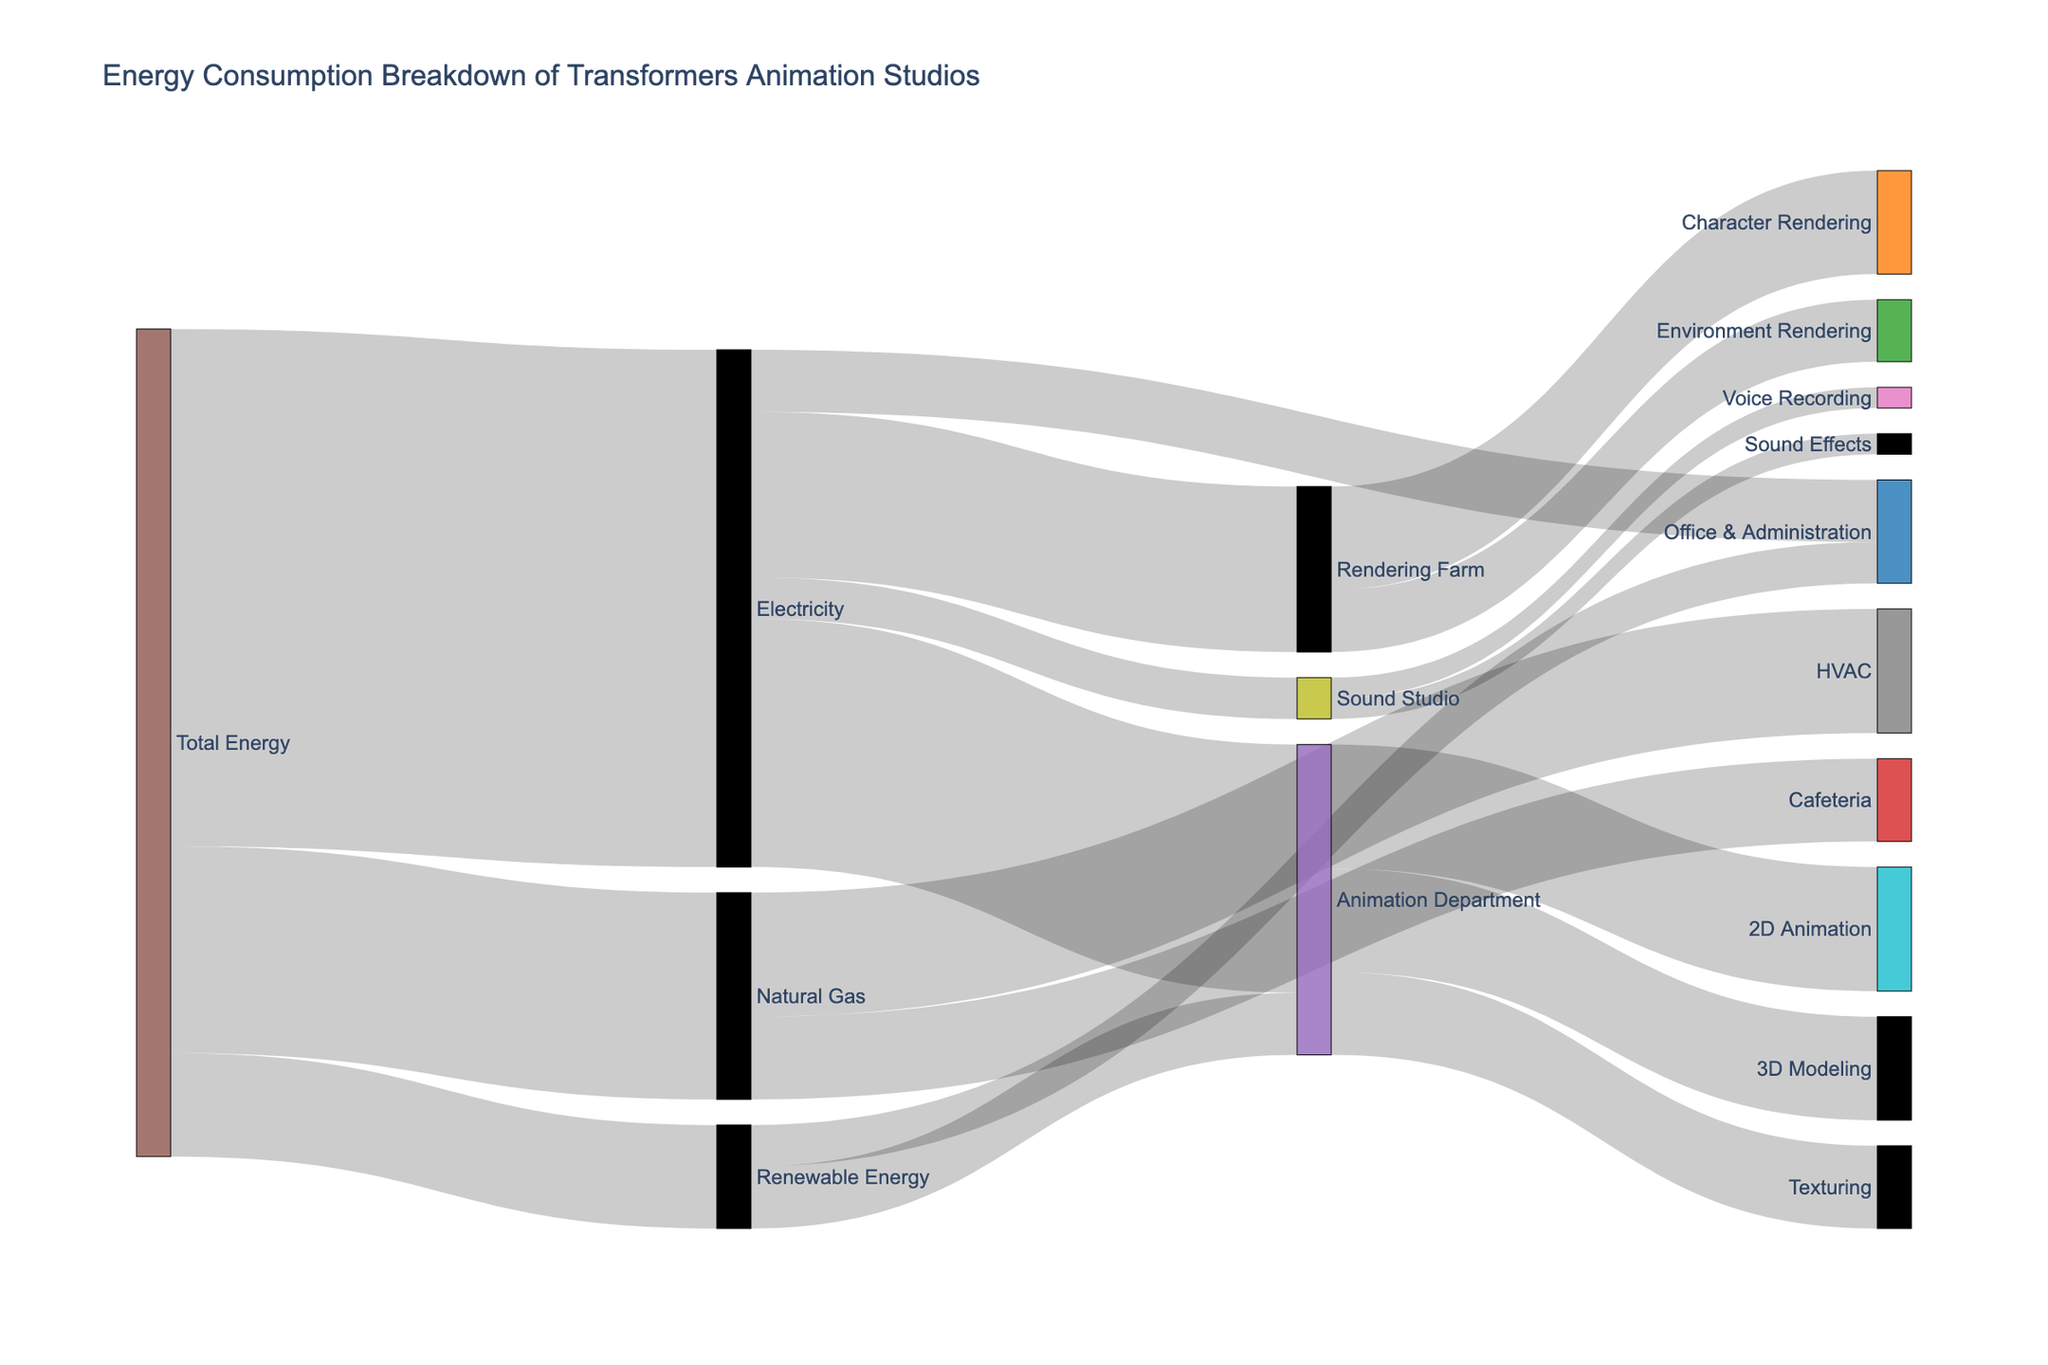What's the total energy consumption? The total energy consumption is the sum of all the energy sources: Electricity (2500), Natural Gas (1000), and Renewable Energy (500). Therefore, it is 2500 + 1000 + 500 = 4000.
Answer: 4000 Which department consumes the most Electricity? The departments and their Electricity consumption are Animation Department (1200), Rendering Farm (800), Office & Administration (300), and Sound Studio (200). The Animation Department has the highest consumption at 1200.
Answer: Animation Department How much energy does the HVAC system consume? The HVAC system uses Natural Gas. As shown, its consumption is 600.
Answer: 600 What is the total energy consumption of the Animation Department (including all sub-departments)? The total energy consumption of the Animation Department is the sum of Electricity (1200) and Renewable Energy (300), which is 1200 + 300 = 1500.
Answer: 1500 Compare the energy consumption between the Rendering Farm and the Sound Studio. The Rendering Farm consumes a total of 800 (Electricity) + 0 (other sources) = 800, while the Sound Studio consumes a total of 200 (Electricity only). Therefore, the Rendering Farm consumes more energy.
Answer: Rendering Farm What percentage of the total energy consumption does Renewable Energy represent? Renewable Energy consumption is 500 out of a total of 4000. The percentage is (500/4000) * 100 = 12.5%.
Answer: 12.5% Which sub-department of the Animation Department consumes the least energy? The sub-departments and their energy consumption are 2D Animation (600), 3D Modeling (500), and Texturing (400). Texturing consumes the least.
Answer: Texturing Compare the energy usage of the Cafeteria and Office & Administration. The Cafeteria uses Natural Gas (400), and Office & Administration uses Electricity (300) + Renewable Energy (200) = 500. Office & Administration uses more energy.
Answer: Office & Administration What is the combined energy consumption of the 2D Animation and 3D Modeling departments? The energy consumption for 2D Animation is 600, and for 3D Modeling it's 500. The combined consumption is 600 + 500 = 1100.
Answer: 1100 How does the energy consumption of Voice Recording and Sound Effects compare? Both Voice Recording and Sound Effects consume 100 each, which makes their consumptions equal.
Answer: Equal 